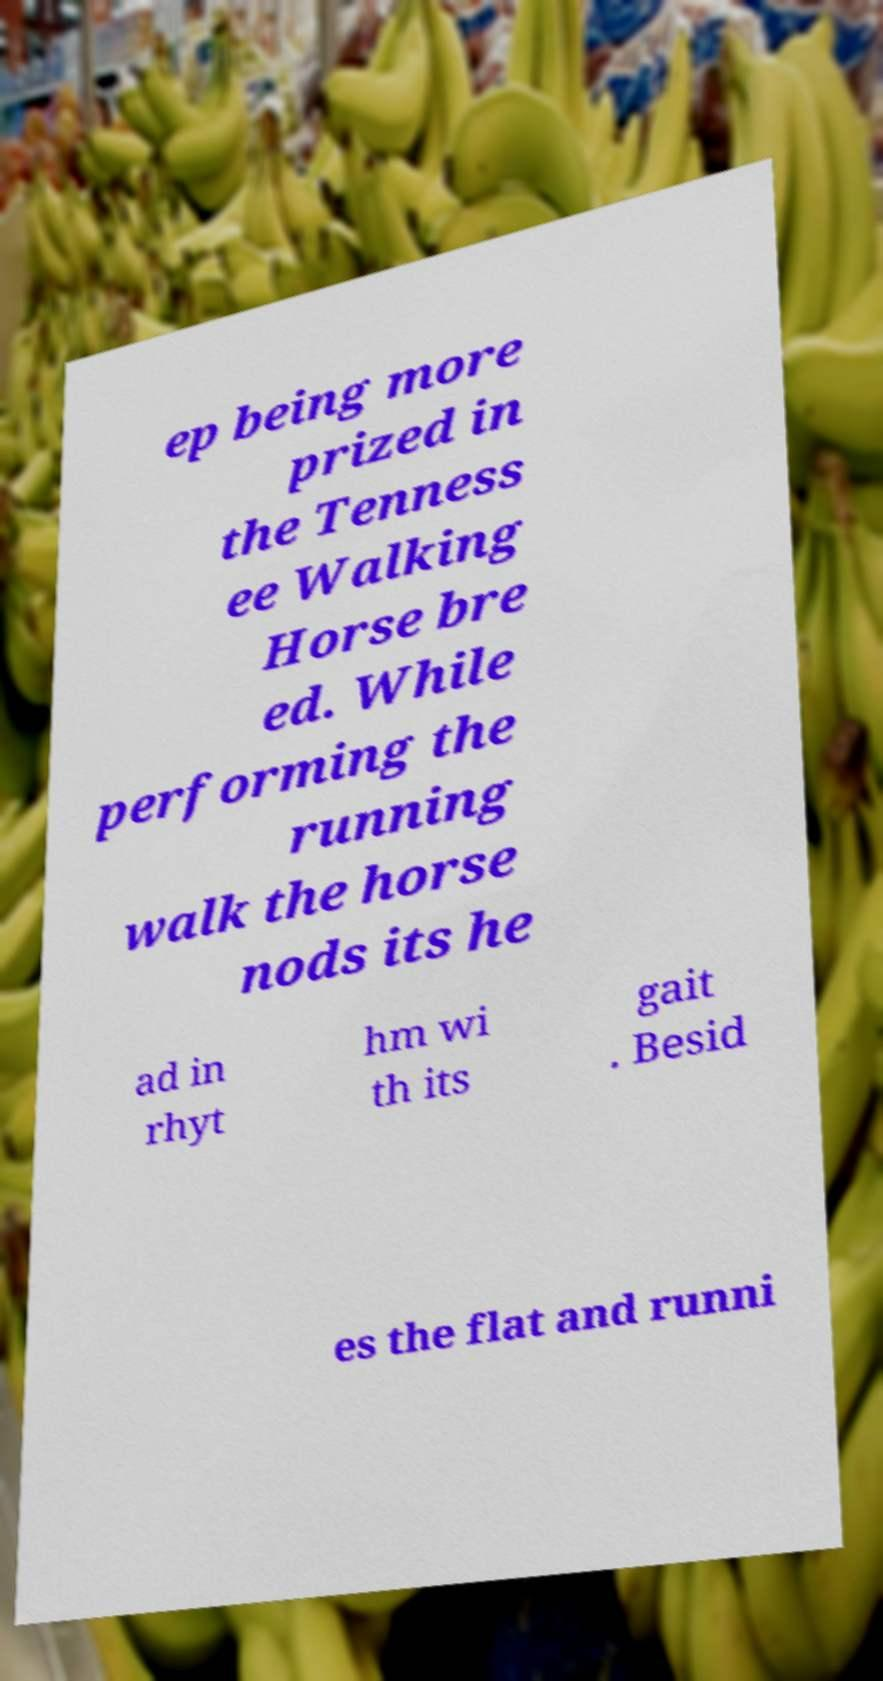Could you extract and type out the text from this image? ep being more prized in the Tenness ee Walking Horse bre ed. While performing the running walk the horse nods its he ad in rhyt hm wi th its gait . Besid es the flat and runni 